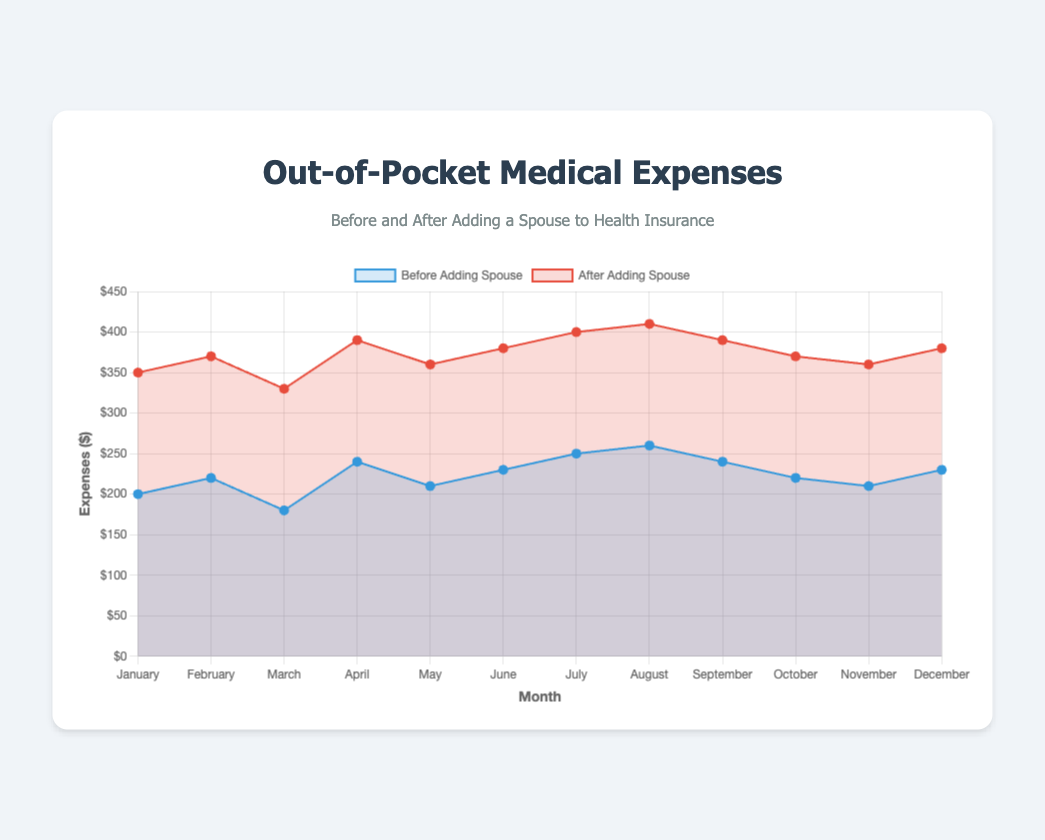What month had the highest out-of-pocket medical expenses after adding a spouse? Look at the data points for the "After Adding Spouse" line. The highest value is in August, which is $410.
Answer: August Which month shows the smallest difference in expenses before and after adding a spouse? Calculate the difference for each month by subtracting the "Before Adding Spouse" values from the "After Adding Spouse" values. The smallest difference is $150 in September and October.
Answer: September, October What is the average out-of-pocket expense before adding a spouse over the year? Sum the "Before Adding Spouse" expenses and divide by the number of months (12). The sum is 2890, so the average is 2890 / 12 ≈ 240.83.
Answer: 240.83 Is there any month where the out-of-pocket expenses were equal before and after adding a spouse? Compare each pair of expenses for equality. None of the months have equal expenses before and after adding a spouse.
Answer: No How much more did you spend in April after adding a spouse compared to before? Subtract the "Before Adding Spouse" value of April ($240) from the "After Adding Spouse" value of April ($390). The difference is $390 - $240 = $150.
Answer: $150 Did the out-of-pocket expenses after adding a spouse ever go below $330? Look at the values in the "After Adding Spouse" dataset. The lowest value is $330 in March.
Answer: Yes Which visual attributes are used to differentiate the 'Before Adding Spouse' and 'After Adding Spouse' datasets? The datasets are differentiated by color (blue for 'Before' and red for 'After') and a filled area under the curve respective to each dataset's color.
Answer: Color and filled area By how much did the expenses increase in February after adding a spouse compared to January? Subtract the "After Adding Spouse" value for January ($350) from the "After Adding Spouse" value for February ($370). The difference is $20.
Answer: $20 During which month did you observe identical expenses trends, either increasing or decreasing, before and after adding a spouse? By checking month-to-month changes, April shows an increase in both datasets from March's values.
Answer: April 